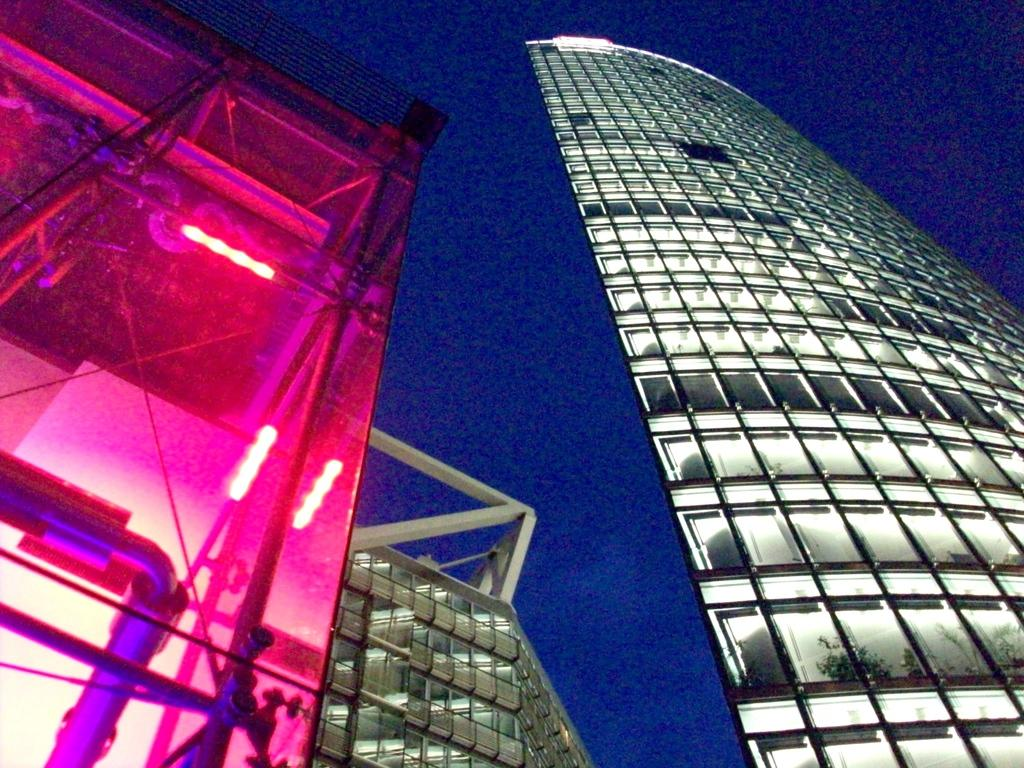What is located in the center of the image? There are buildings in the center of the image. What can be seen in the background of the image? The sky is visible in the background of the image. What type of can is being used to build the brick wall in the image? There is no can or brick wall present in the image; it only features buildings and the sky. 